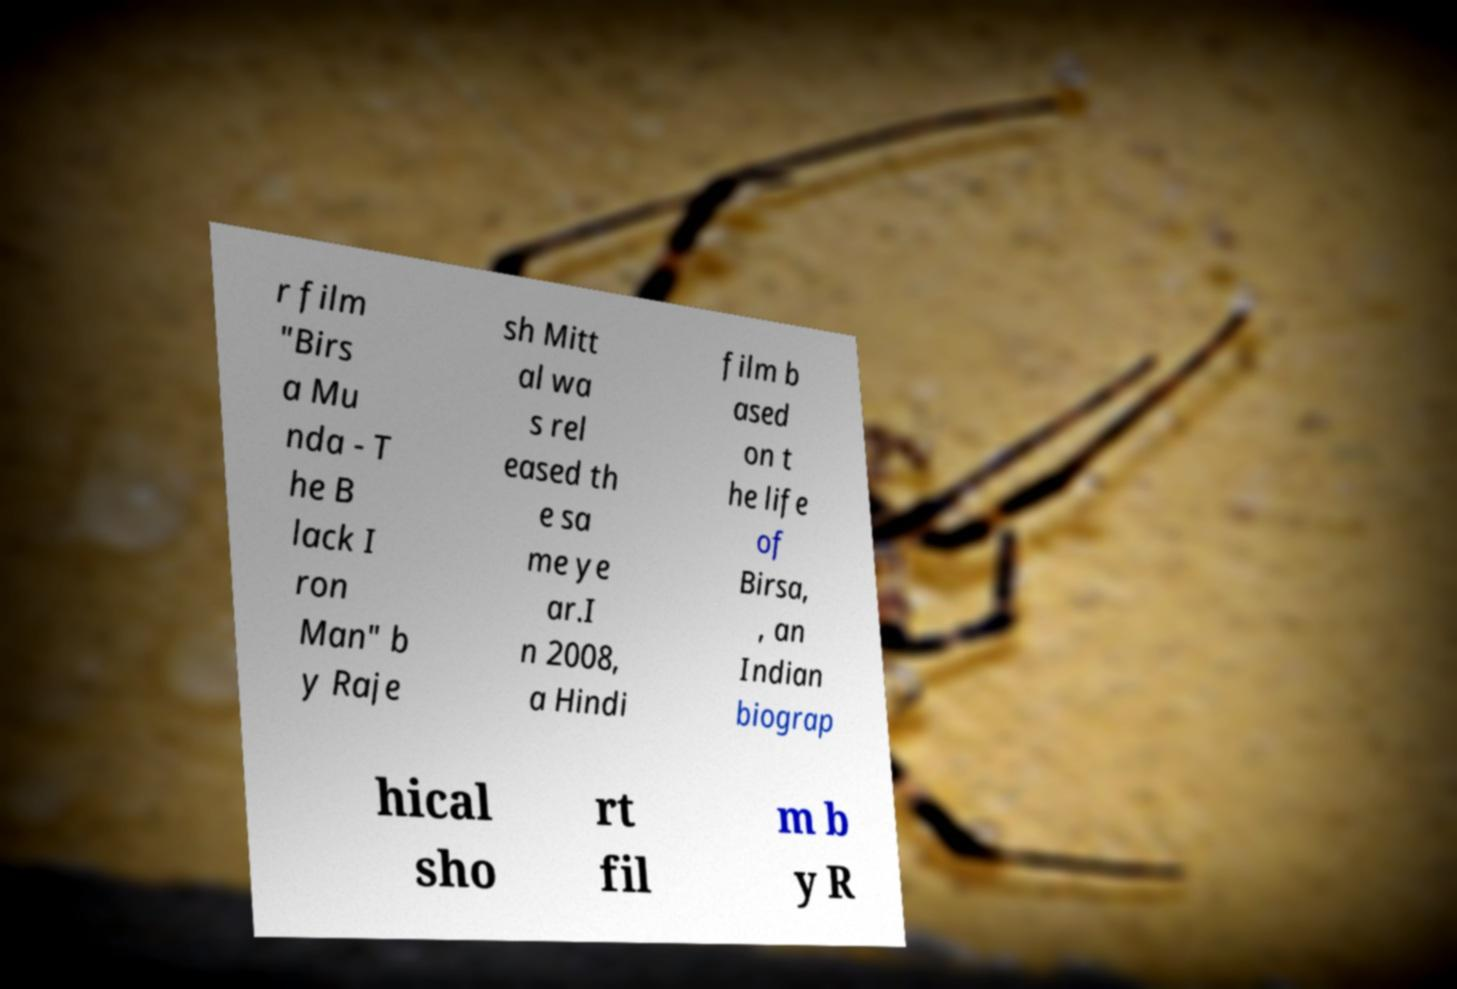Can you read and provide the text displayed in the image?This photo seems to have some interesting text. Can you extract and type it out for me? r film "Birs a Mu nda - T he B lack I ron Man" b y Raje sh Mitt al wa s rel eased th e sa me ye ar.I n 2008, a Hindi film b ased on t he life of Birsa, , an Indian biograp hical sho rt fil m b y R 